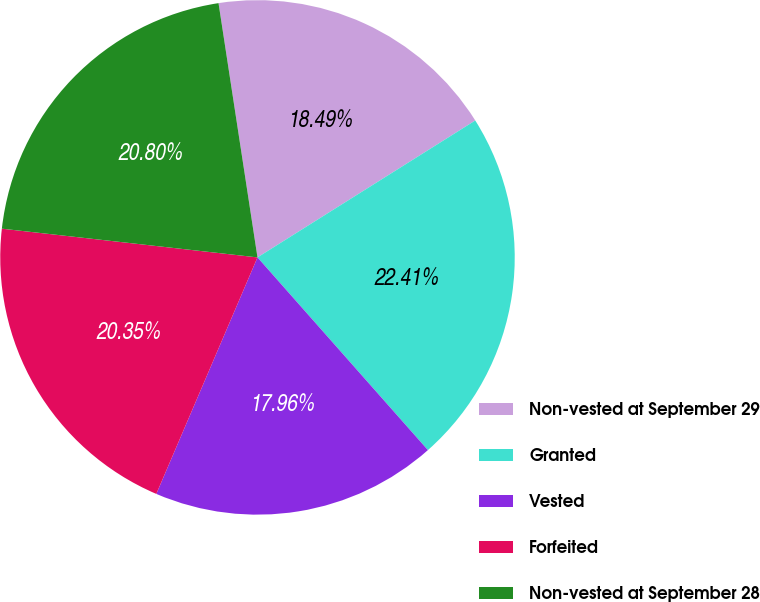<chart> <loc_0><loc_0><loc_500><loc_500><pie_chart><fcel>Non-vested at September 29<fcel>Granted<fcel>Vested<fcel>Forfeited<fcel>Non-vested at September 28<nl><fcel>18.49%<fcel>22.41%<fcel>17.96%<fcel>20.35%<fcel>20.8%<nl></chart> 